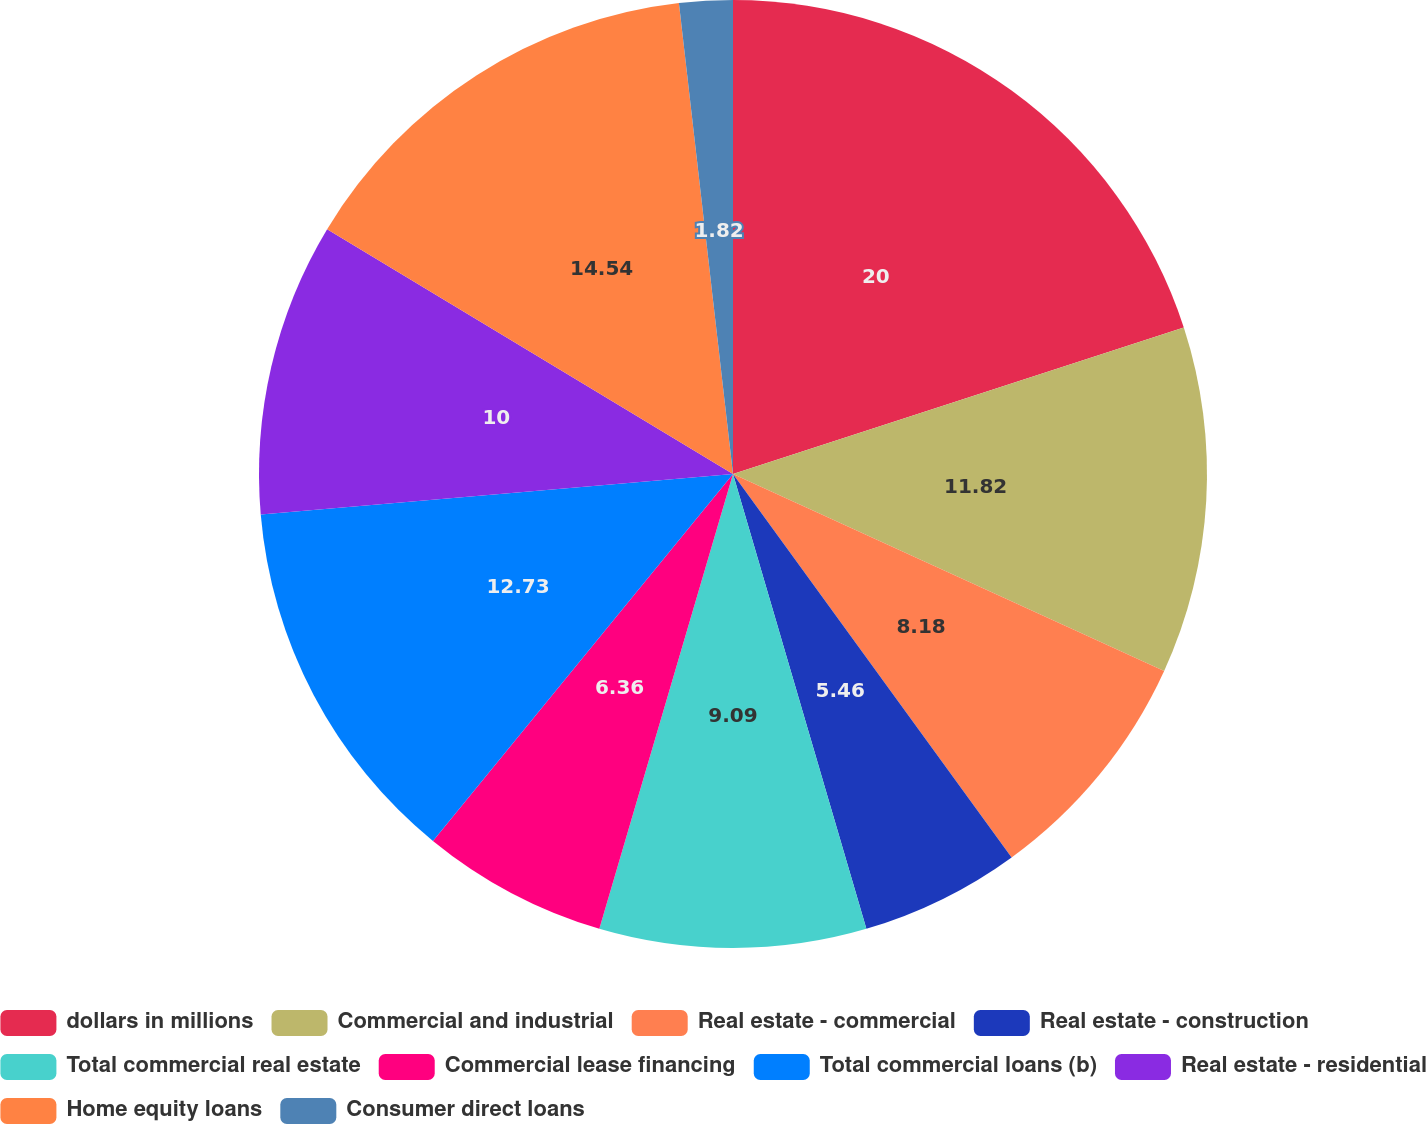<chart> <loc_0><loc_0><loc_500><loc_500><pie_chart><fcel>dollars in millions<fcel>Commercial and industrial<fcel>Real estate - commercial<fcel>Real estate - construction<fcel>Total commercial real estate<fcel>Commercial lease financing<fcel>Total commercial loans (b)<fcel>Real estate - residential<fcel>Home equity loans<fcel>Consumer direct loans<nl><fcel>20.0%<fcel>11.82%<fcel>8.18%<fcel>5.46%<fcel>9.09%<fcel>6.36%<fcel>12.73%<fcel>10.0%<fcel>14.54%<fcel>1.82%<nl></chart> 